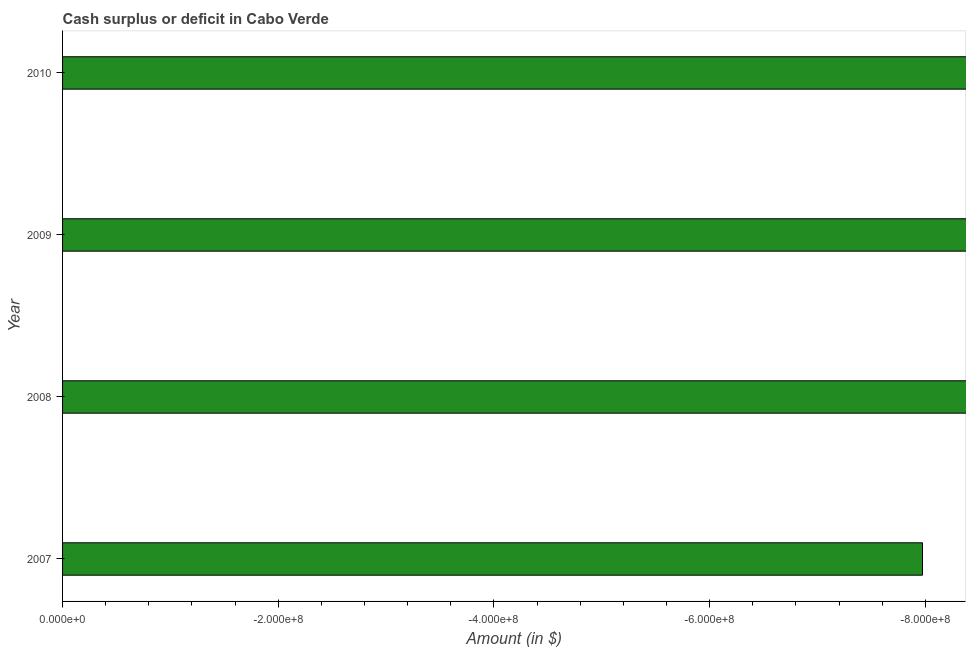Does the graph contain any zero values?
Ensure brevity in your answer.  Yes. Does the graph contain grids?
Provide a short and direct response. No. What is the title of the graph?
Ensure brevity in your answer.  Cash surplus or deficit in Cabo Verde. What is the label or title of the X-axis?
Make the answer very short. Amount (in $). Across all years, what is the minimum cash surplus or deficit?
Your response must be concise. 0. What is the average cash surplus or deficit per year?
Give a very brief answer. 0. In how many years, is the cash surplus or deficit greater than the average cash surplus or deficit taken over all years?
Your answer should be compact. 0. How many years are there in the graph?
Give a very brief answer. 4. What is the difference between two consecutive major ticks on the X-axis?
Offer a very short reply. 2.00e+08. What is the Amount (in $) of 2007?
Make the answer very short. 0. What is the Amount (in $) in 2009?
Offer a very short reply. 0. What is the Amount (in $) of 2010?
Your answer should be compact. 0. 